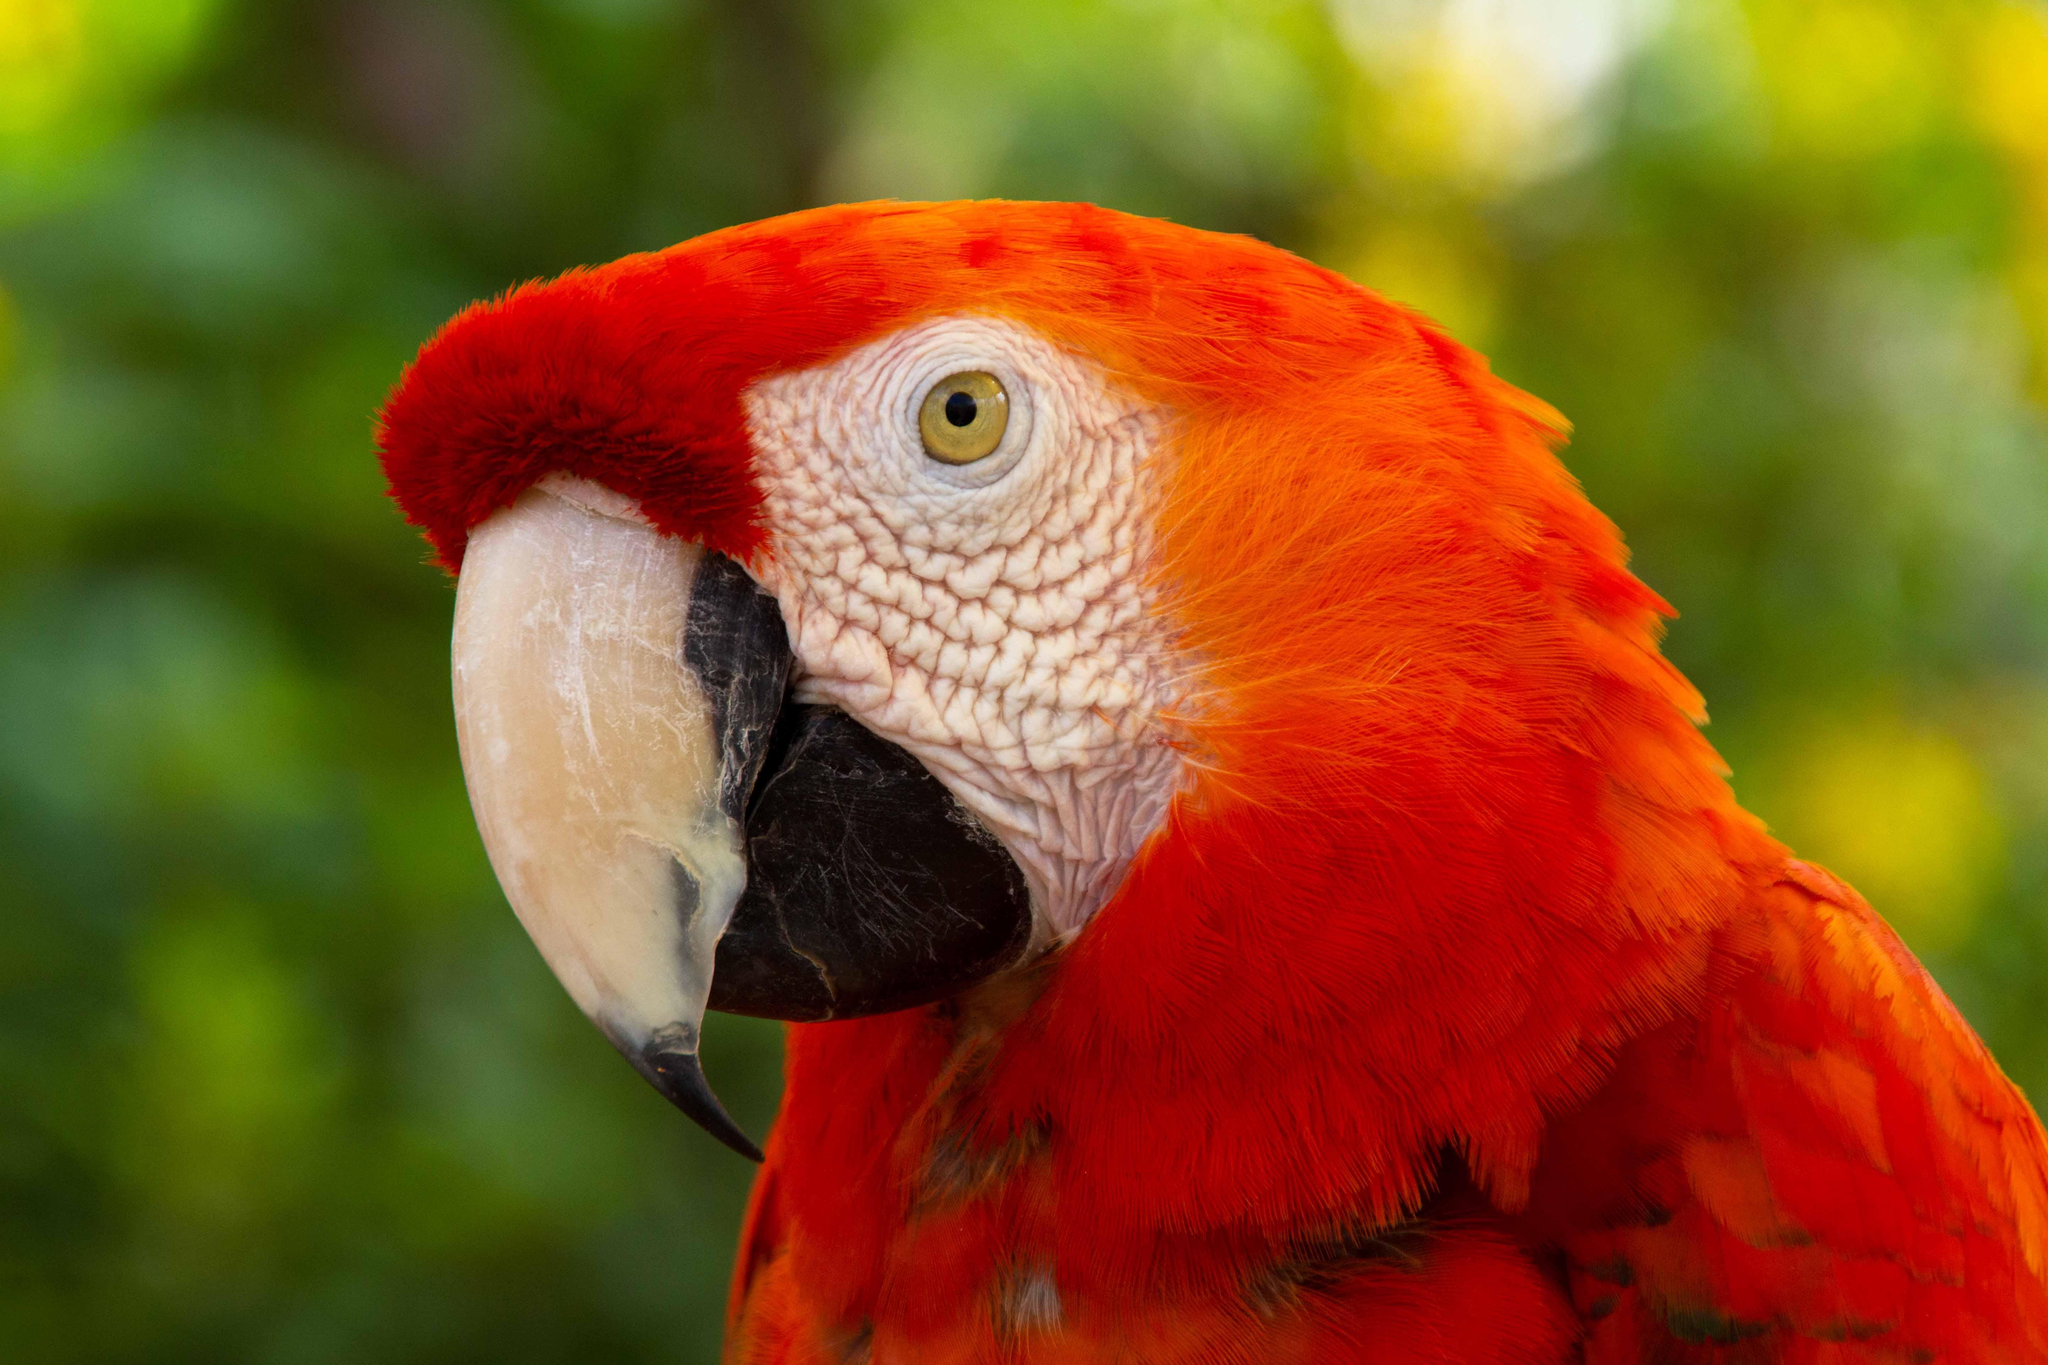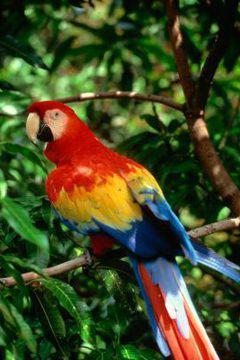The first image is the image on the left, the second image is the image on the right. For the images shown, is this caption "One of the images contains exactly five birds." true? Answer yes or no. No. 